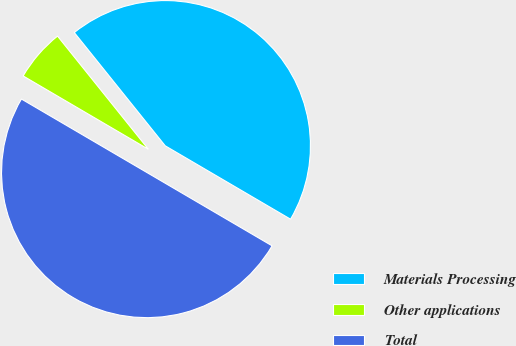<chart> <loc_0><loc_0><loc_500><loc_500><pie_chart><fcel>Materials Processing<fcel>Other applications<fcel>Total<nl><fcel>44.2%<fcel>5.8%<fcel>50.0%<nl></chart> 